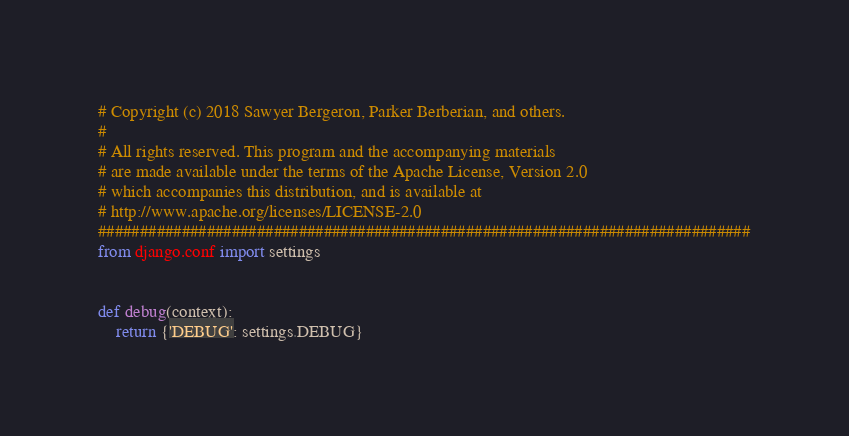<code> <loc_0><loc_0><loc_500><loc_500><_Python_># Copyright (c) 2018 Sawyer Bergeron, Parker Berberian, and others.
#
# All rights reserved. This program and the accompanying materials
# are made available under the terms of the Apache License, Version 2.0
# which accompanies this distribution, and is available at
# http://www.apache.org/licenses/LICENSE-2.0
##############################################################################
from django.conf import settings


def debug(context):
    return {'DEBUG': settings.DEBUG}
</code> 